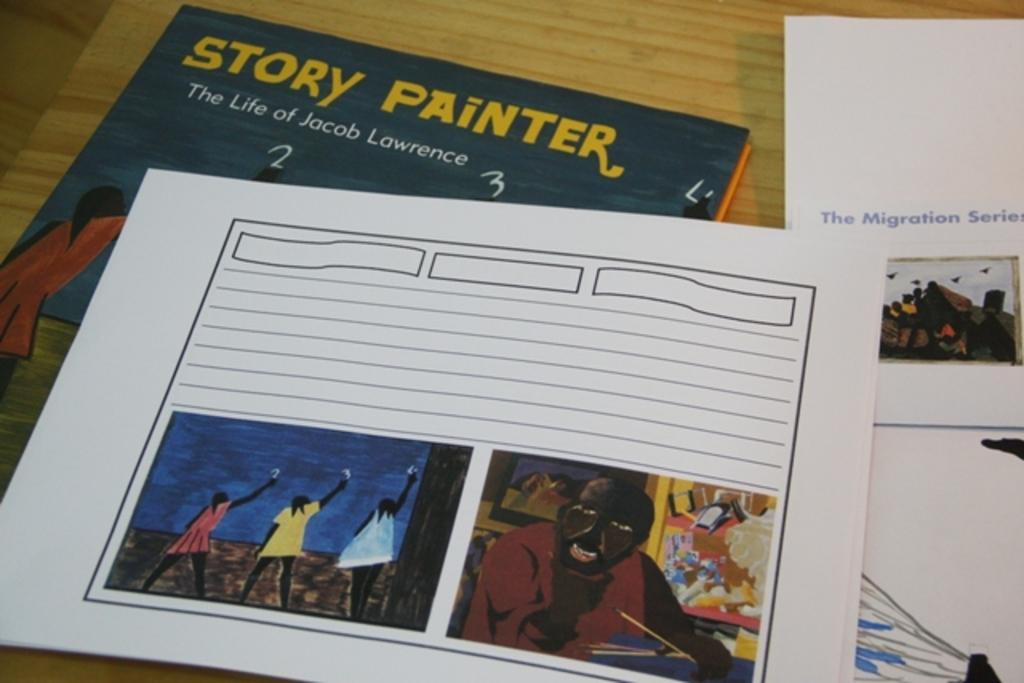<image>
Offer a succinct explanation of the picture presented. a book that is called Story Painter next to another book 